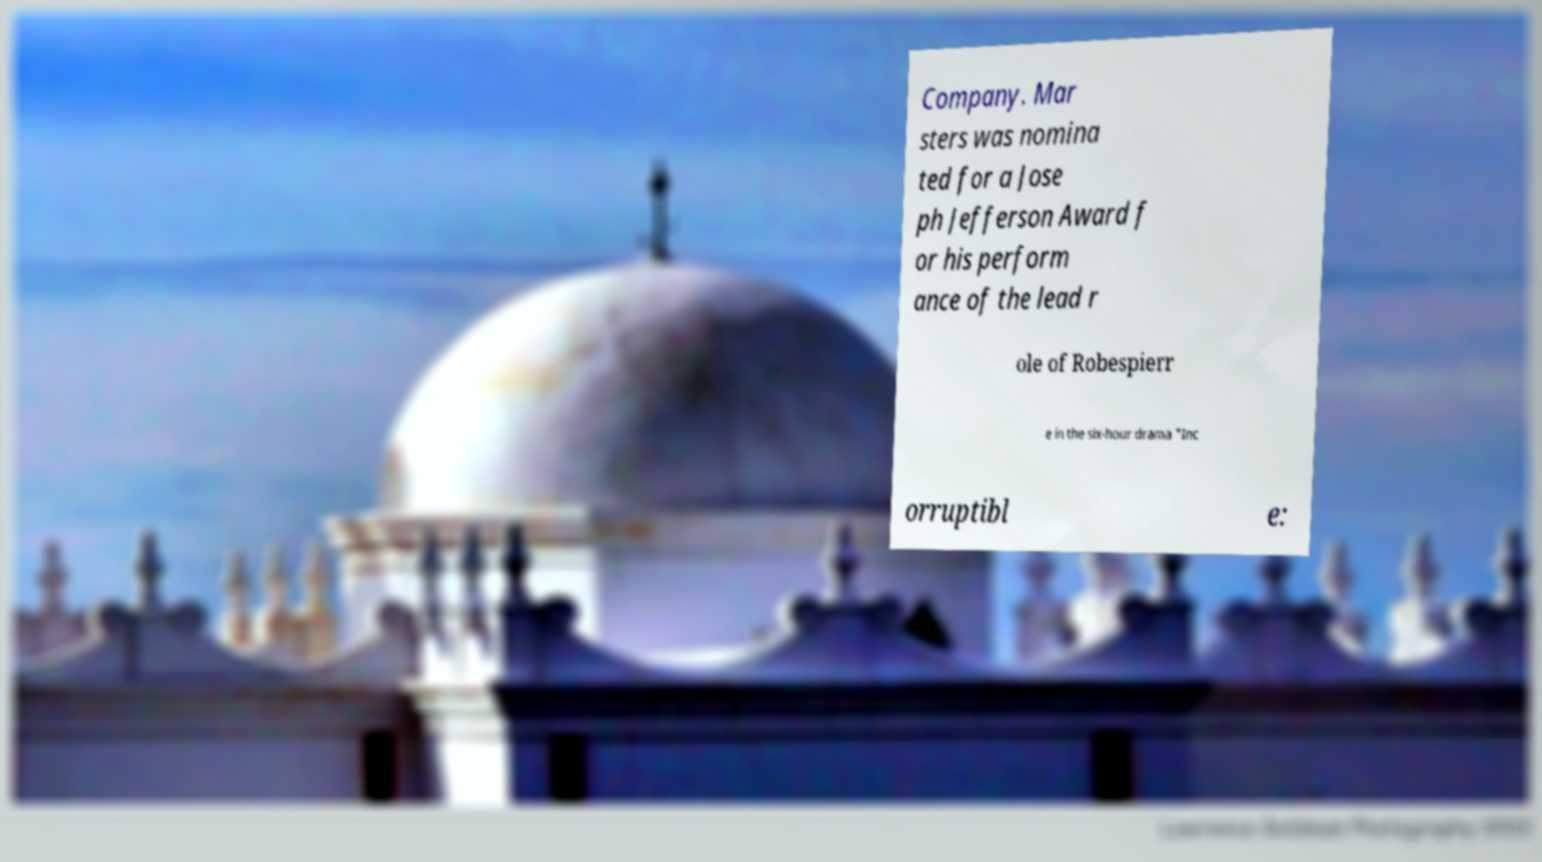There's text embedded in this image that I need extracted. Can you transcribe it verbatim? Company. Mar sters was nomina ted for a Jose ph Jefferson Award f or his perform ance of the lead r ole of Robespierr e in the six-hour drama "Inc orruptibl e: 